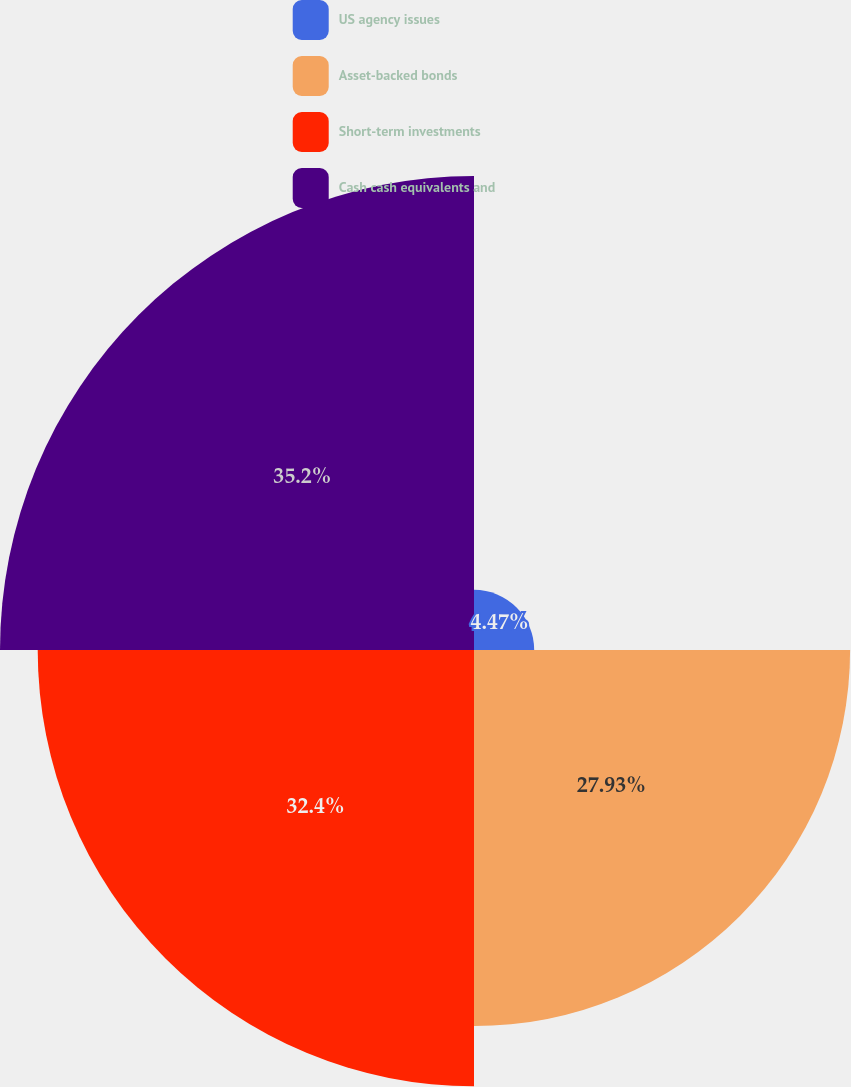Convert chart to OTSL. <chart><loc_0><loc_0><loc_500><loc_500><pie_chart><fcel>US agency issues<fcel>Asset-backed bonds<fcel>Short-term investments<fcel>Cash cash equivalents and<nl><fcel>4.47%<fcel>27.93%<fcel>32.4%<fcel>35.2%<nl></chart> 